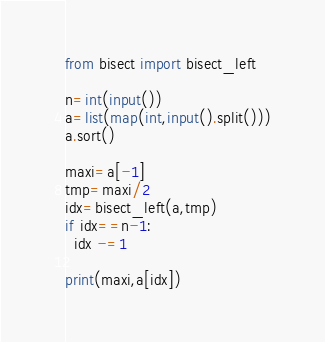Convert code to text. <code><loc_0><loc_0><loc_500><loc_500><_Python_>from bisect import bisect_left

n=int(input())
a=list(map(int,input().split()))
a.sort()

maxi=a[-1]
tmp=maxi/2
idx=bisect_left(a,tmp)
if idx==n-1:
  idx -=1

print(maxi,a[idx])</code> 